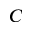<formula> <loc_0><loc_0><loc_500><loc_500>C</formula> 